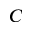<formula> <loc_0><loc_0><loc_500><loc_500>C</formula> 